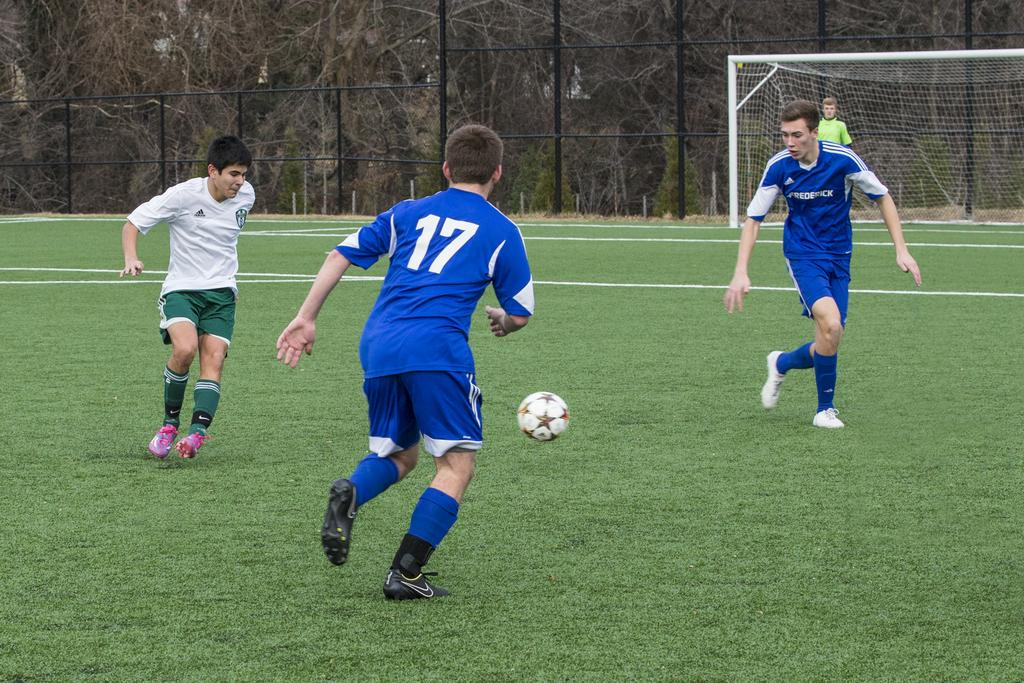What object can be seen in the image? There is a ball in the image. How many people are present in the image? There are three people on the ground in the image. What type of vegetation is visible in the background of the image? There are trees in the background of the image. What structure is present in the background of the image? There is a football net in the background of the image. What else can be seen in the background of the image? There is a fence and a person in the background of the image. What type of music is being played by the rabbit in the image? There is no rabbit present in the image, and therefore no music being played. 